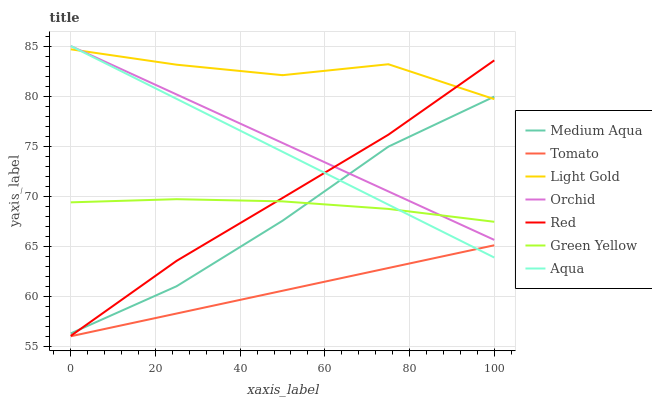Does Tomato have the minimum area under the curve?
Answer yes or no. Yes. Does Light Gold have the maximum area under the curve?
Answer yes or no. Yes. Does Aqua have the minimum area under the curve?
Answer yes or no. No. Does Aqua have the maximum area under the curve?
Answer yes or no. No. Is Aqua the smoothest?
Answer yes or no. Yes. Is Light Gold the roughest?
Answer yes or no. Yes. Is Medium Aqua the smoothest?
Answer yes or no. No. Is Medium Aqua the roughest?
Answer yes or no. No. Does Tomato have the lowest value?
Answer yes or no. Yes. Does Aqua have the lowest value?
Answer yes or no. No. Does Orchid have the highest value?
Answer yes or no. Yes. Does Medium Aqua have the highest value?
Answer yes or no. No. Is Tomato less than Light Gold?
Answer yes or no. Yes. Is Light Gold greater than Green Yellow?
Answer yes or no. Yes. Does Red intersect Medium Aqua?
Answer yes or no. Yes. Is Red less than Medium Aqua?
Answer yes or no. No. Is Red greater than Medium Aqua?
Answer yes or no. No. Does Tomato intersect Light Gold?
Answer yes or no. No. 